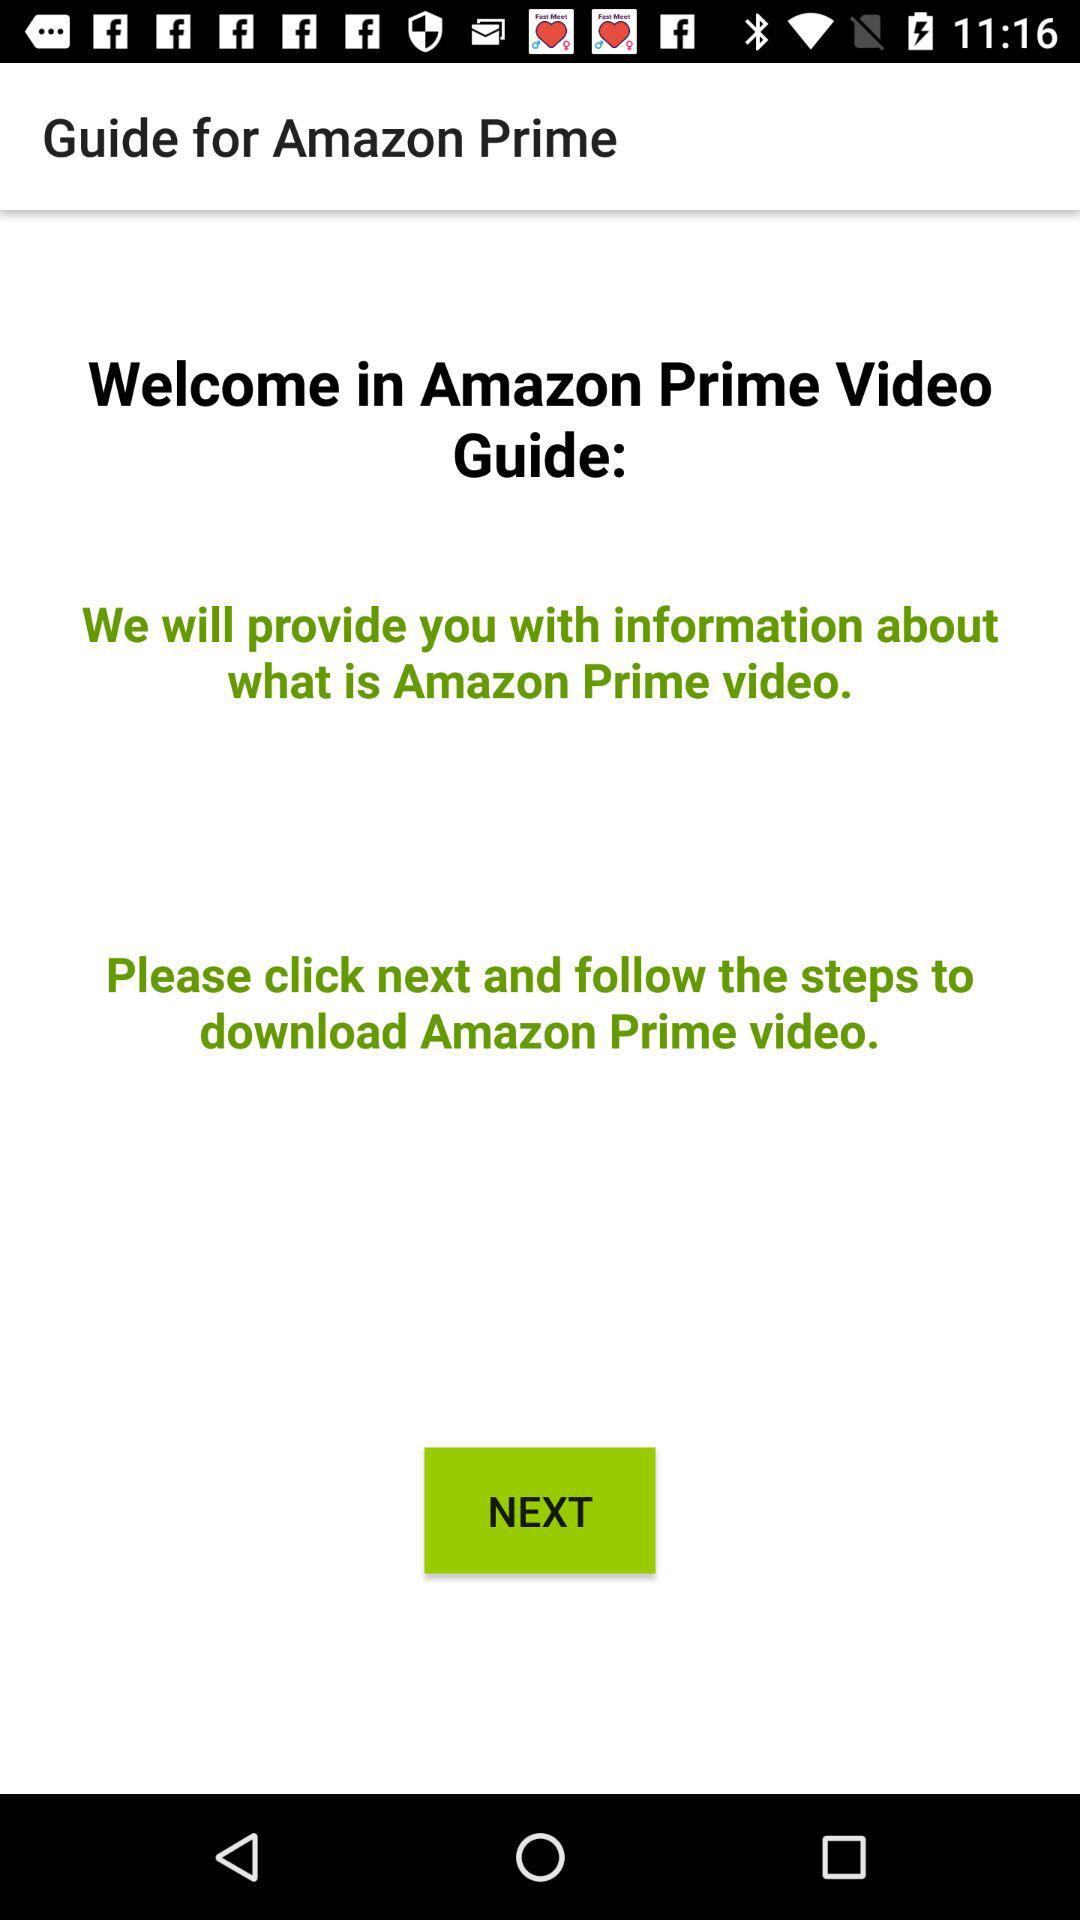What button do I click to download Amazon Prime Video? You should click the "NEXT" button to download Amazon Prime Video. 